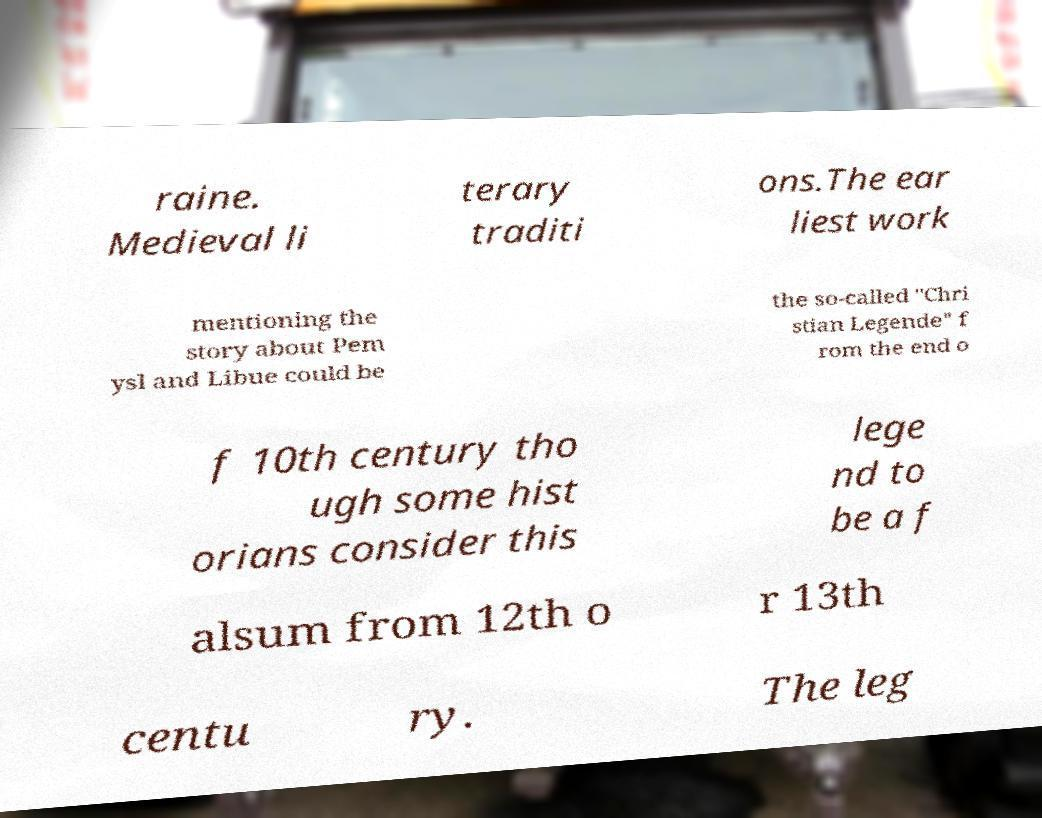Could you assist in decoding the text presented in this image and type it out clearly? raine. Medieval li terary traditi ons.The ear liest work mentioning the story about Pem ysl and Libue could be the so-called "Chri stian Legende" f rom the end o f 10th century tho ugh some hist orians consider this lege nd to be a f alsum from 12th o r 13th centu ry. The leg 